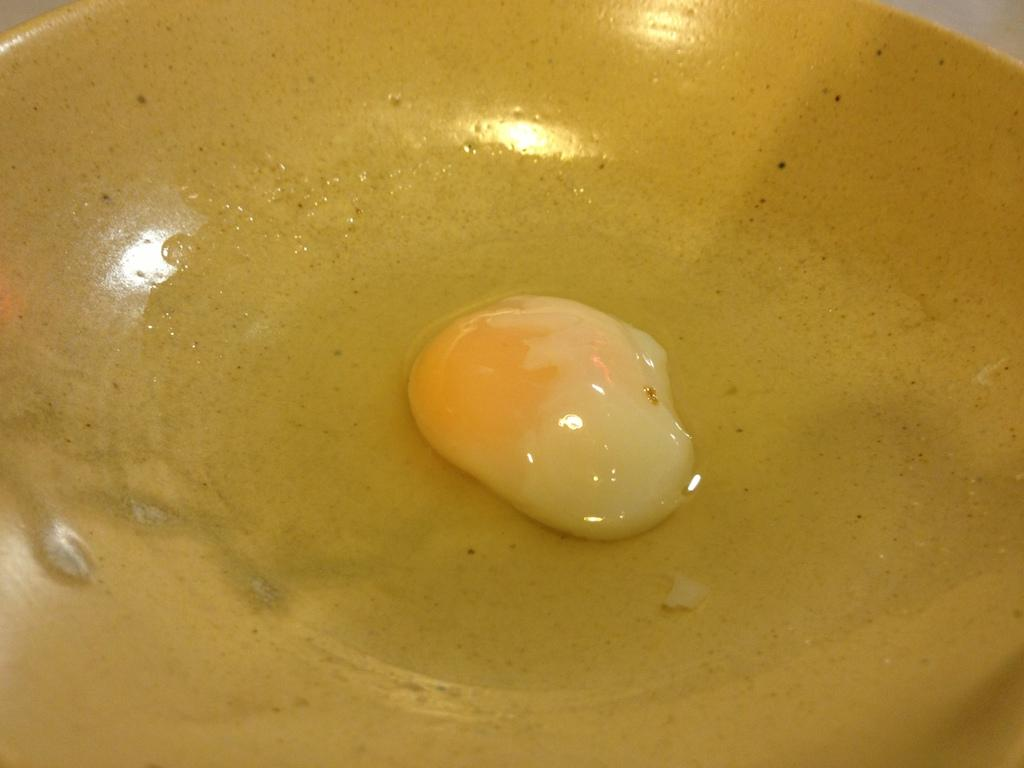What is on the plate in the image? There is the yolk of an egg present in the plate. Can you describe the appearance of the yolk? The yolk appears to be a bright yellow color. What type of bead is being used to decorate the office in the image? There is no mention of beads or an office in the image; it only features a plate with the yolk of an egg. 